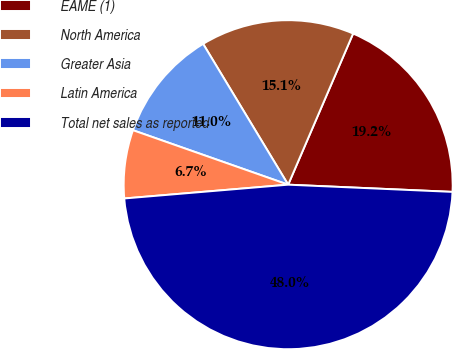Convert chart to OTSL. <chart><loc_0><loc_0><loc_500><loc_500><pie_chart><fcel>EAME (1)<fcel>North America<fcel>Greater Asia<fcel>Latin America<fcel>Total net sales as reported<nl><fcel>19.24%<fcel>15.11%<fcel>10.98%<fcel>6.71%<fcel>47.97%<nl></chart> 